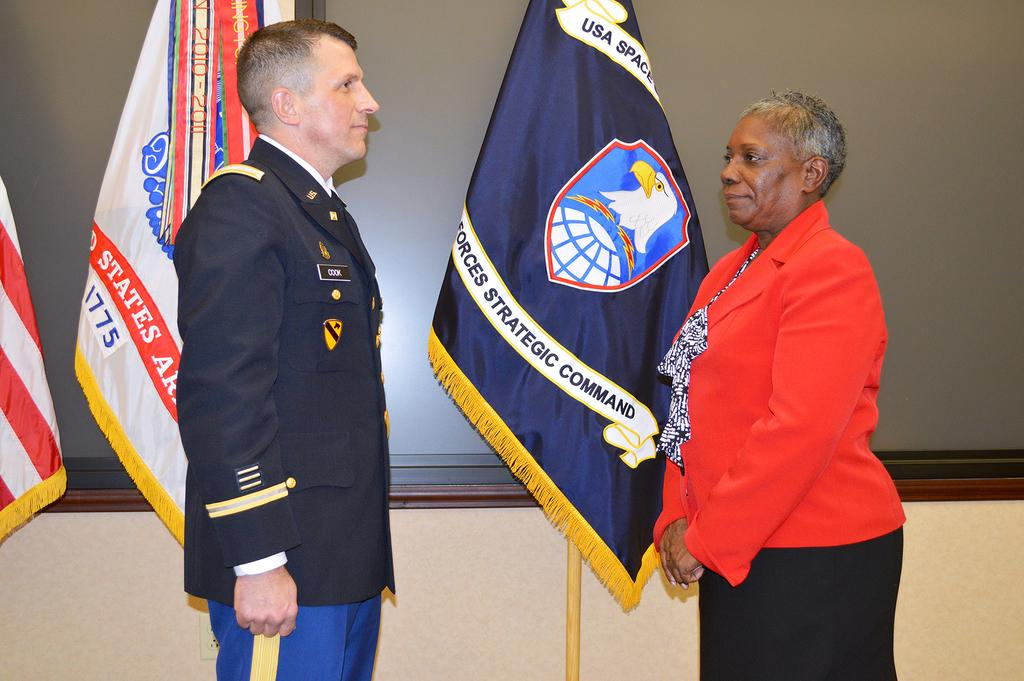<image>
Create a compact narrative representing the image presented. Soldier standing in front of a flag which says "Strategic Command" on it. 